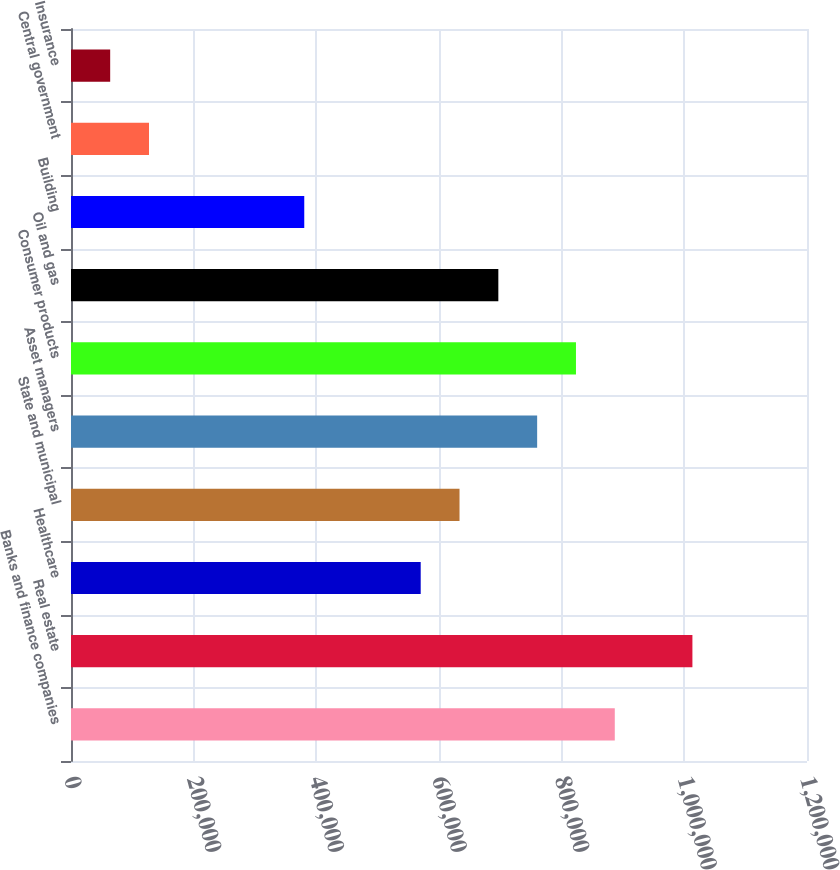Convert chart to OTSL. <chart><loc_0><loc_0><loc_500><loc_500><bar_chart><fcel>Banks and finance companies<fcel>Real estate<fcel>Healthcare<fcel>State and municipal<fcel>Asset managers<fcel>Consumer products<fcel>Oil and gas<fcel>Building<fcel>Central government<fcel>Insurance<nl><fcel>886602<fcel>1.01317e+06<fcel>570172<fcel>633458<fcel>760030<fcel>823316<fcel>696744<fcel>380314<fcel>127169<fcel>63883.1<nl></chart> 